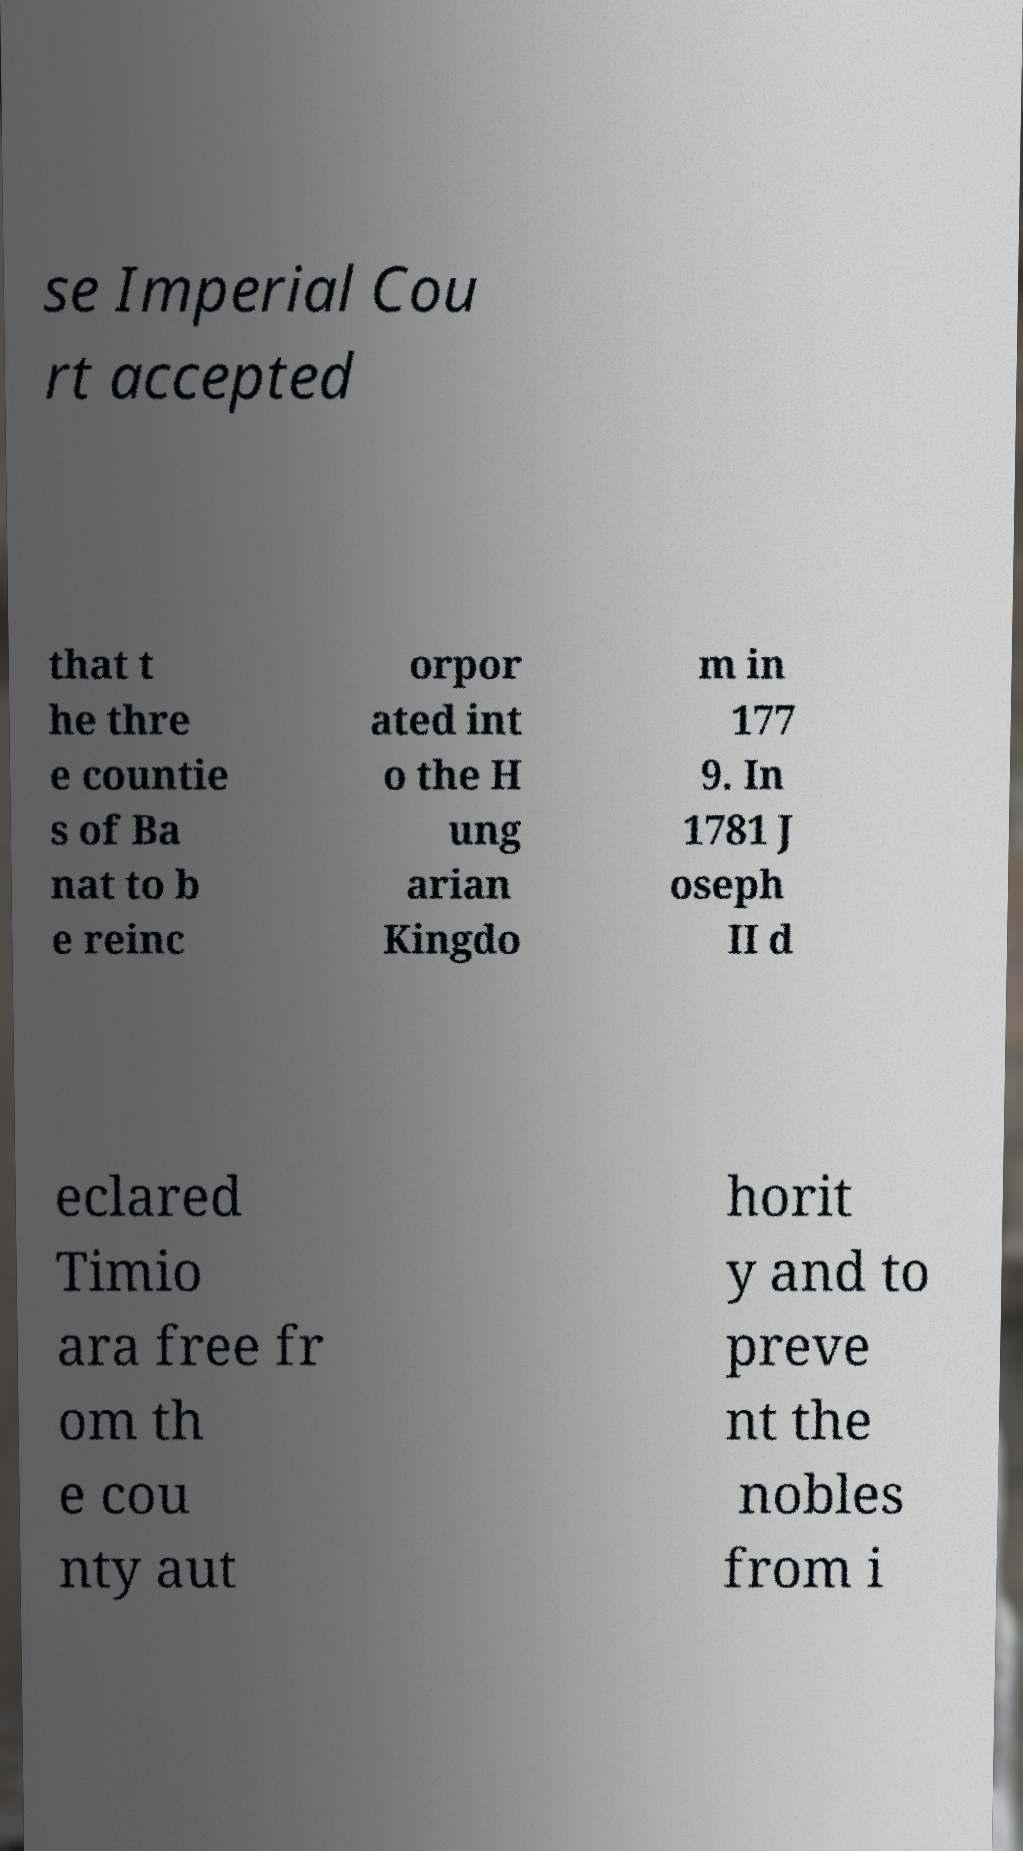What messages or text are displayed in this image? I need them in a readable, typed format. se Imperial Cou rt accepted that t he thre e countie s of Ba nat to b e reinc orpor ated int o the H ung arian Kingdo m in 177 9. In 1781 J oseph II d eclared Timio ara free fr om th e cou nty aut horit y and to preve nt the nobles from i 